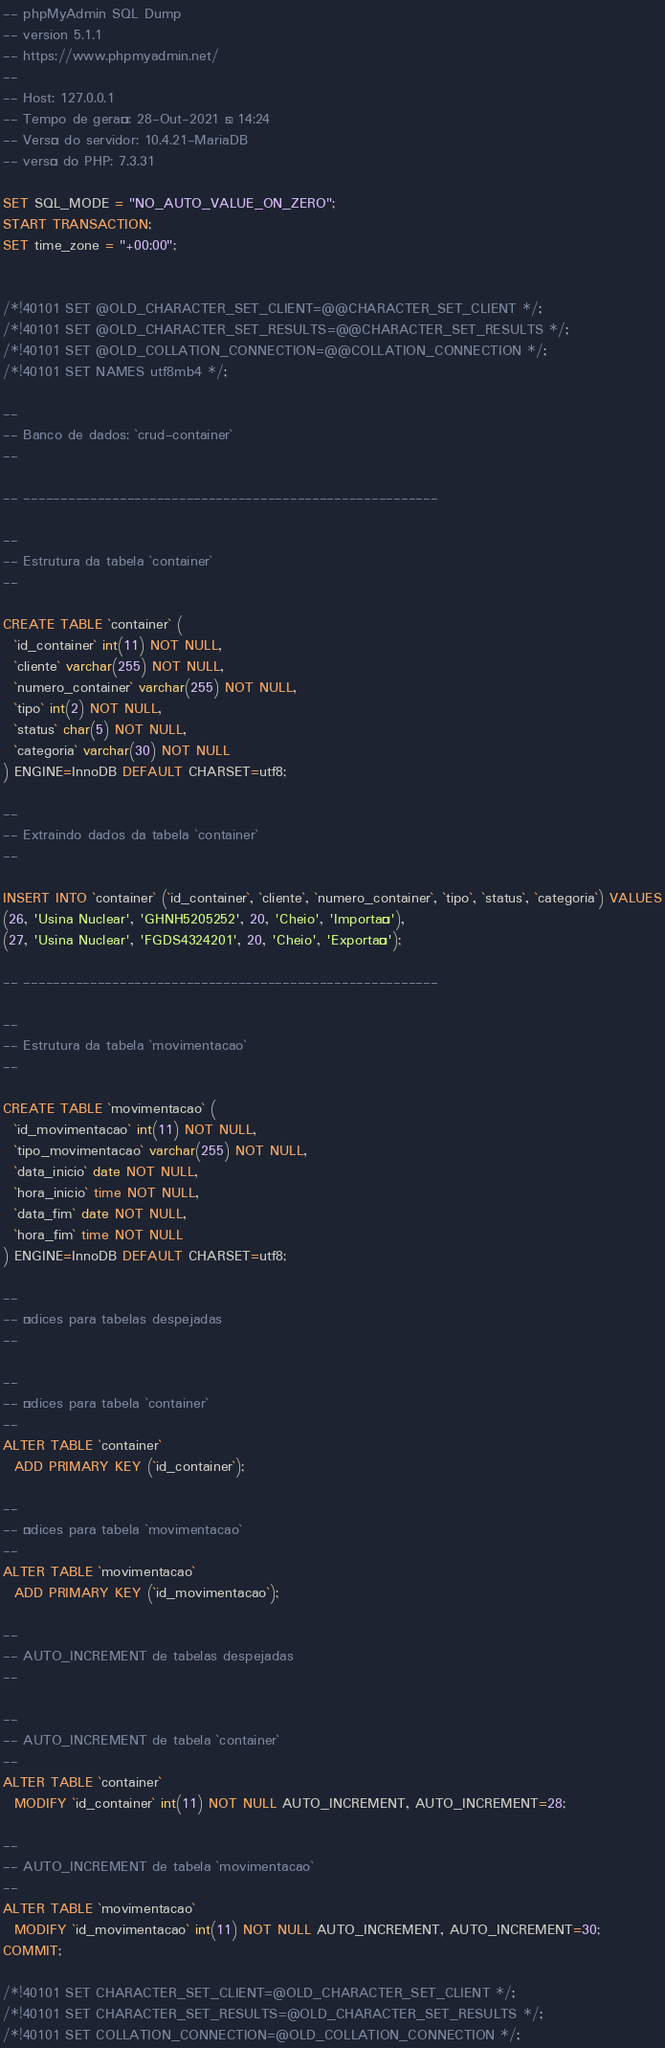Convert code to text. <code><loc_0><loc_0><loc_500><loc_500><_SQL_>-- phpMyAdmin SQL Dump
-- version 5.1.1
-- https://www.phpmyadmin.net/
--
-- Host: 127.0.0.1
-- Tempo de geração: 28-Out-2021 às 14:24
-- Versão do servidor: 10.4.21-MariaDB
-- versão do PHP: 7.3.31

SET SQL_MODE = "NO_AUTO_VALUE_ON_ZERO";
START TRANSACTION;
SET time_zone = "+00:00";


/*!40101 SET @OLD_CHARACTER_SET_CLIENT=@@CHARACTER_SET_CLIENT */;
/*!40101 SET @OLD_CHARACTER_SET_RESULTS=@@CHARACTER_SET_RESULTS */;
/*!40101 SET @OLD_COLLATION_CONNECTION=@@COLLATION_CONNECTION */;
/*!40101 SET NAMES utf8mb4 */;

--
-- Banco de dados: `crud-container`
--

-- --------------------------------------------------------

--
-- Estrutura da tabela `container`
--

CREATE TABLE `container` (
  `id_container` int(11) NOT NULL,
  `cliente` varchar(255) NOT NULL,
  `numero_container` varchar(255) NOT NULL,
  `tipo` int(2) NOT NULL,
  `status` char(5) NOT NULL,
  `categoria` varchar(30) NOT NULL
) ENGINE=InnoDB DEFAULT CHARSET=utf8;

--
-- Extraindo dados da tabela `container`
--

INSERT INTO `container` (`id_container`, `cliente`, `numero_container`, `tipo`, `status`, `categoria`) VALUES
(26, 'Usina Nuclear', 'GHNH5205252', 20, 'Cheio', 'Importação'),
(27, 'Usina Nuclear', 'FGDS4324201', 20, 'Cheio', 'Exportação');

-- --------------------------------------------------------

--
-- Estrutura da tabela `movimentacao`
--

CREATE TABLE `movimentacao` (
  `id_movimentacao` int(11) NOT NULL,
  `tipo_movimentacao` varchar(255) NOT NULL,
  `data_inicio` date NOT NULL,
  `hora_inicio` time NOT NULL,
  `data_fim` date NOT NULL,
  `hora_fim` time NOT NULL
) ENGINE=InnoDB DEFAULT CHARSET=utf8;

--
-- Índices para tabelas despejadas
--

--
-- Índices para tabela `container`
--
ALTER TABLE `container`
  ADD PRIMARY KEY (`id_container`);

--
-- Índices para tabela `movimentacao`
--
ALTER TABLE `movimentacao`
  ADD PRIMARY KEY (`id_movimentacao`);

--
-- AUTO_INCREMENT de tabelas despejadas
--

--
-- AUTO_INCREMENT de tabela `container`
--
ALTER TABLE `container`
  MODIFY `id_container` int(11) NOT NULL AUTO_INCREMENT, AUTO_INCREMENT=28;

--
-- AUTO_INCREMENT de tabela `movimentacao`
--
ALTER TABLE `movimentacao`
  MODIFY `id_movimentacao` int(11) NOT NULL AUTO_INCREMENT, AUTO_INCREMENT=30;
COMMIT;

/*!40101 SET CHARACTER_SET_CLIENT=@OLD_CHARACTER_SET_CLIENT */;
/*!40101 SET CHARACTER_SET_RESULTS=@OLD_CHARACTER_SET_RESULTS */;
/*!40101 SET COLLATION_CONNECTION=@OLD_COLLATION_CONNECTION */;
</code> 